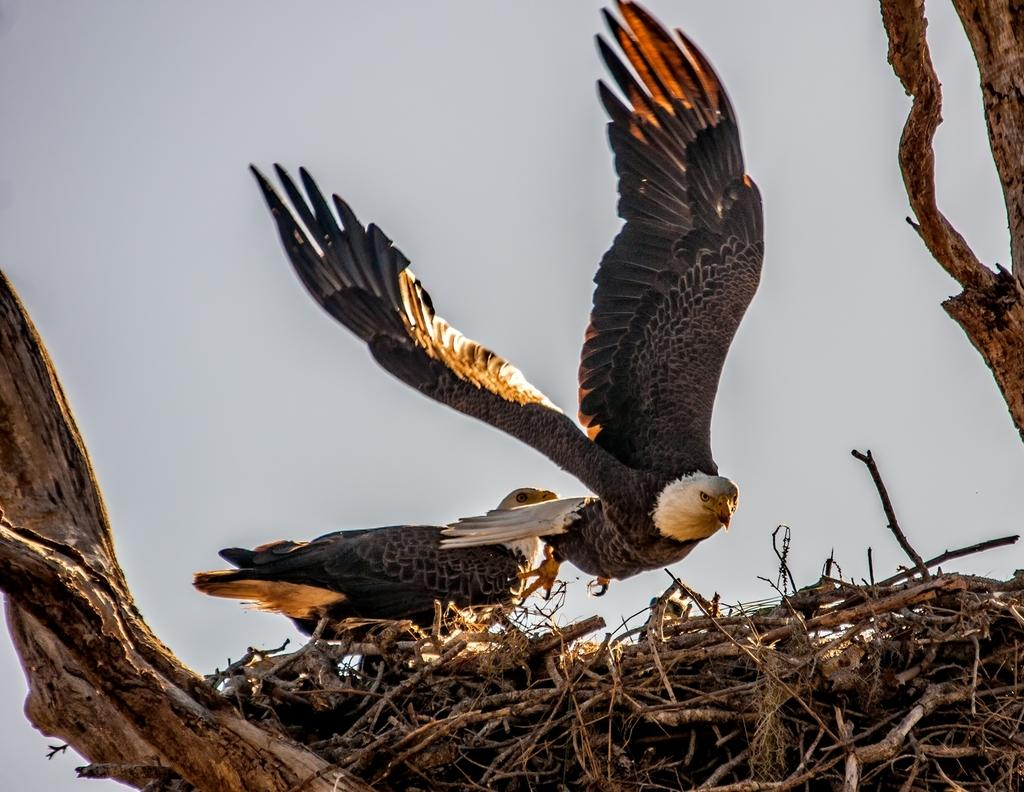How many birds are visible in the image? There are two birds in the image. What is one bird doing in the image? One bird is flying from a nest. What is the other bird doing in the image? The other bird is standing on a nest. Where is the nest located in the image? The nest is located on a tree. What type of ring can be seen on the bird's beak in the image? There is no ring visible on any bird's beak in the image. What type of fuel is being used by the birds to fly in the image? Birds do not use fuel to fly; they have wings that allow them to fly using their own energy. 